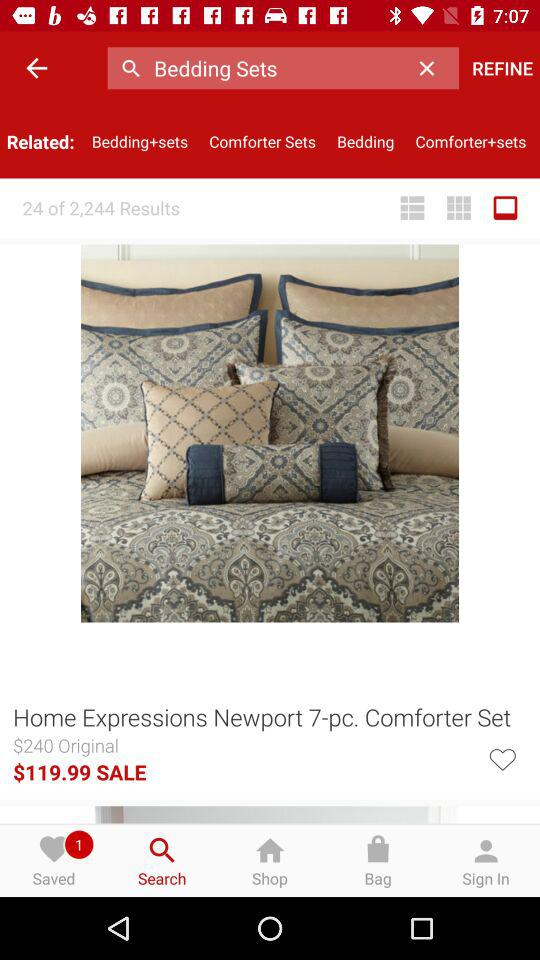Which result am I on out of 2244? You are on result 24. 